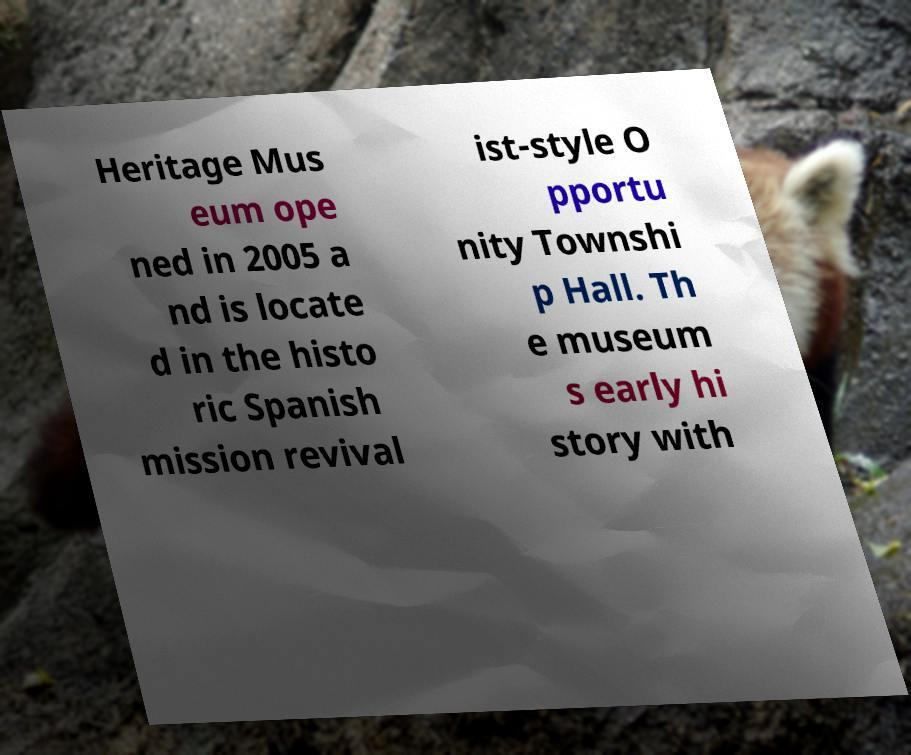Can you accurately transcribe the text from the provided image for me? Heritage Mus eum ope ned in 2005 a nd is locate d in the histo ric Spanish mission revival ist-style O pportu nity Townshi p Hall. Th e museum s early hi story with 